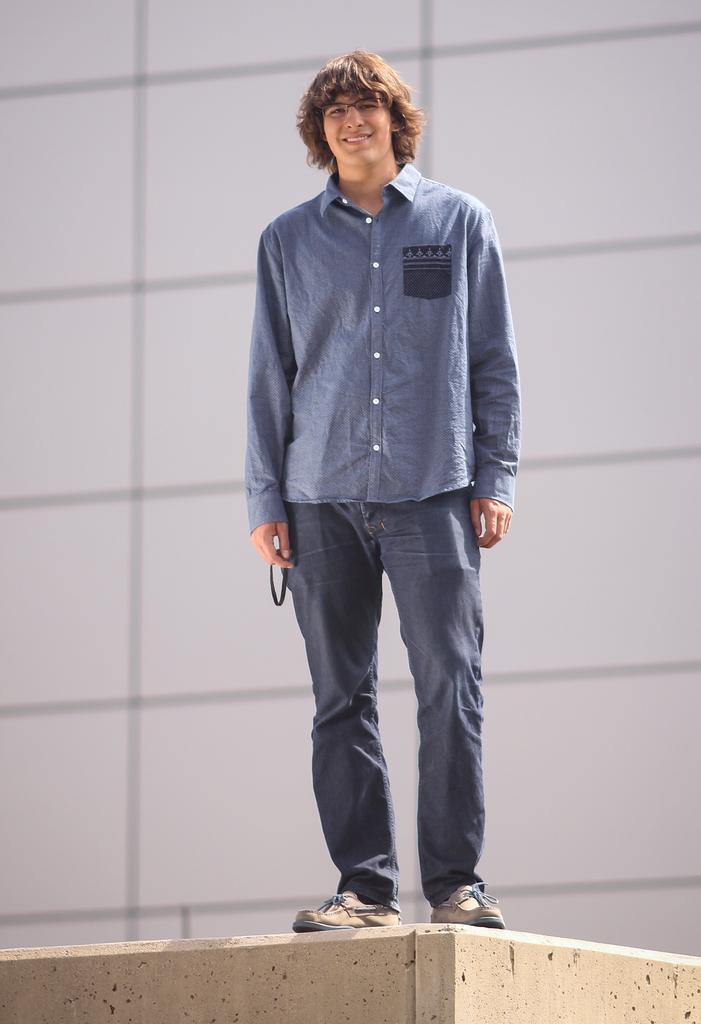Please provide a concise description of this image. In this image in the center there is one person who is standing on a wall, and in the background there is a wall. 